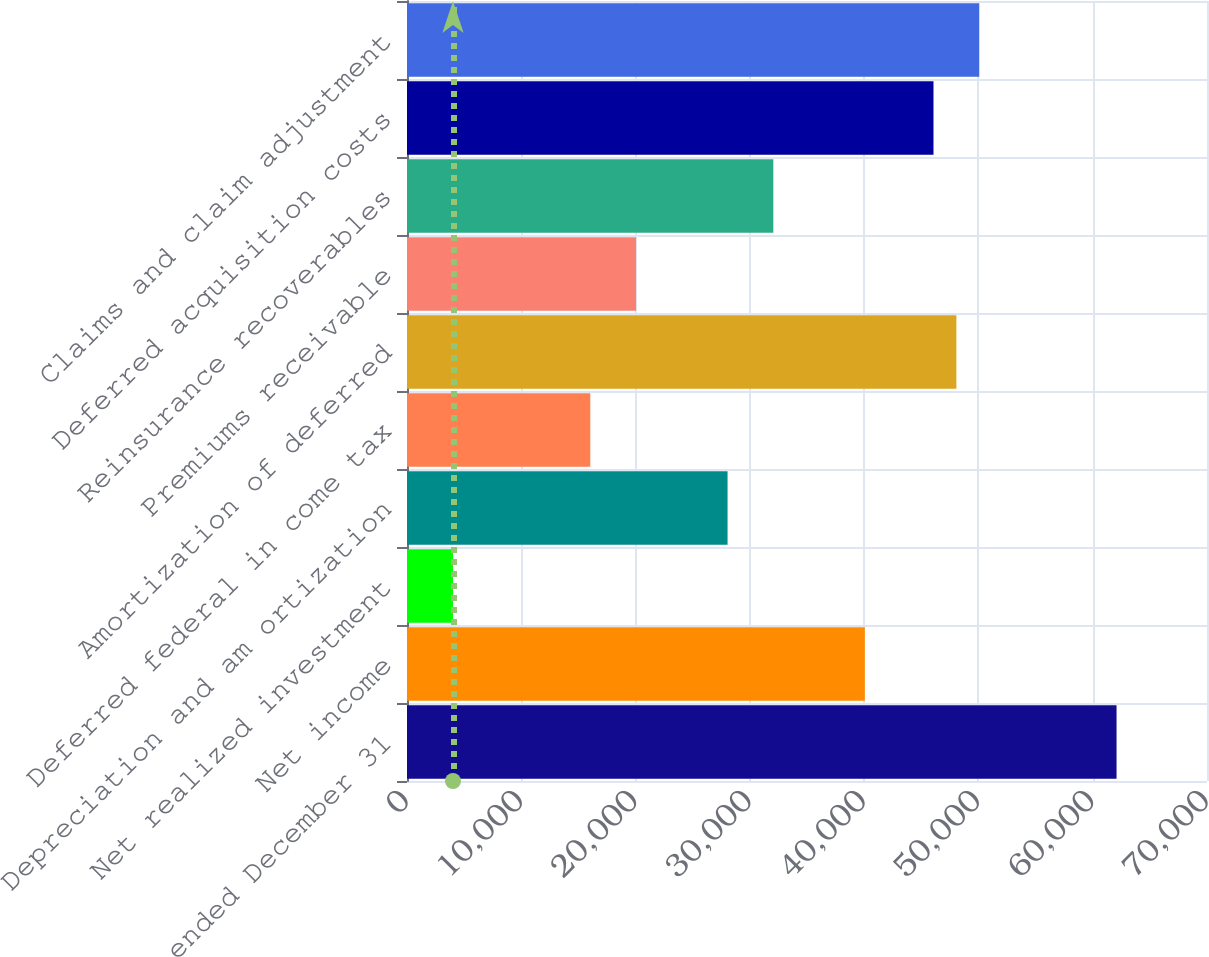<chart> <loc_0><loc_0><loc_500><loc_500><bar_chart><fcel>For the year ended December 31<fcel>Net income<fcel>Net realized investment<fcel>Depreciation and am ortization<fcel>Deferred federal in come tax<fcel>Amortization of deferred<fcel>Premiums receivable<fcel>Reinsurance recoverables<fcel>Deferred acquisition costs<fcel>Claims and claim adjustment<nl><fcel>62085.1<fcel>40062<fcel>4024.2<fcel>28049.4<fcel>16036.8<fcel>48070.4<fcel>20041<fcel>32053.6<fcel>46068.3<fcel>50072.5<nl></chart> 